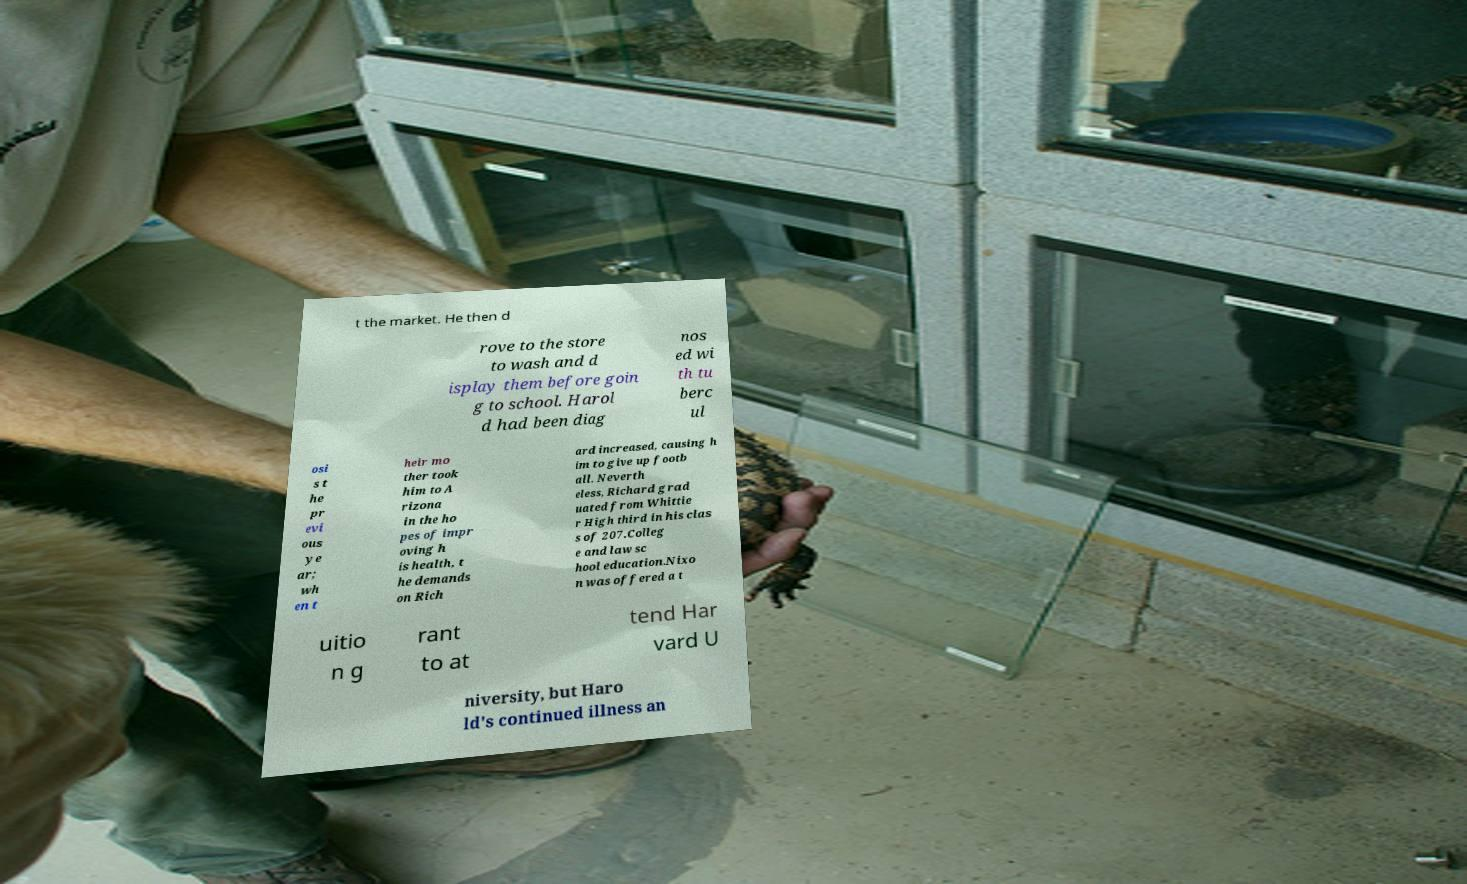For documentation purposes, I need the text within this image transcribed. Could you provide that? t the market. He then d rove to the store to wash and d isplay them before goin g to school. Harol d had been diag nos ed wi th tu berc ul osi s t he pr evi ous ye ar; wh en t heir mo ther took him to A rizona in the ho pes of impr oving h is health, t he demands on Rich ard increased, causing h im to give up footb all. Neverth eless, Richard grad uated from Whittie r High third in his clas s of 207.Colleg e and law sc hool education.Nixo n was offered a t uitio n g rant to at tend Har vard U niversity, but Haro ld's continued illness an 